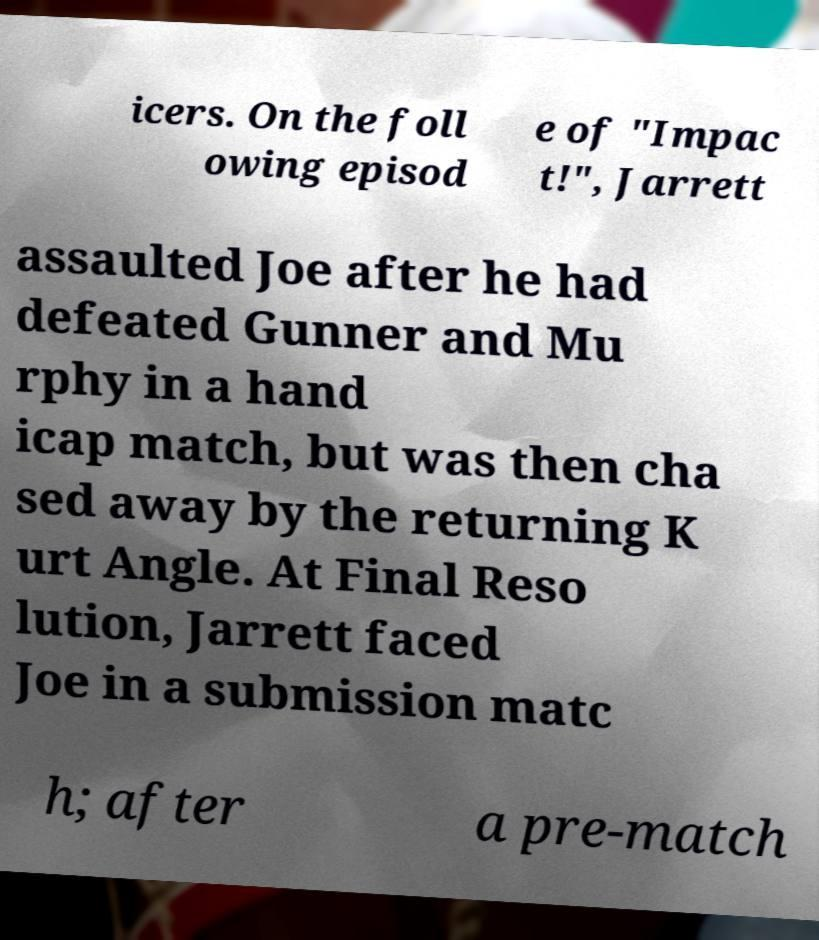Please read and relay the text visible in this image. What does it say? icers. On the foll owing episod e of "Impac t!", Jarrett assaulted Joe after he had defeated Gunner and Mu rphy in a hand icap match, but was then cha sed away by the returning K urt Angle. At Final Reso lution, Jarrett faced Joe in a submission matc h; after a pre-match 